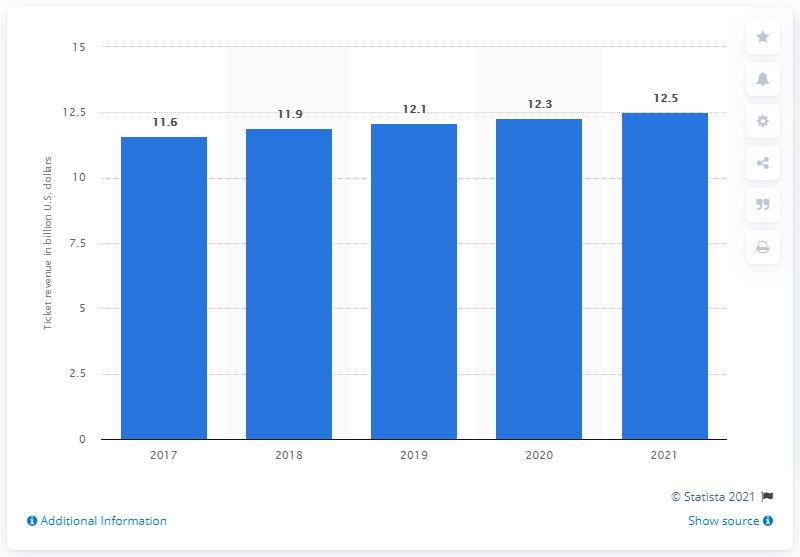List a handful of essential elements in this visual. By 2021, ticket sales in the U.S. are projected to reach 12.5 billion dollars. 